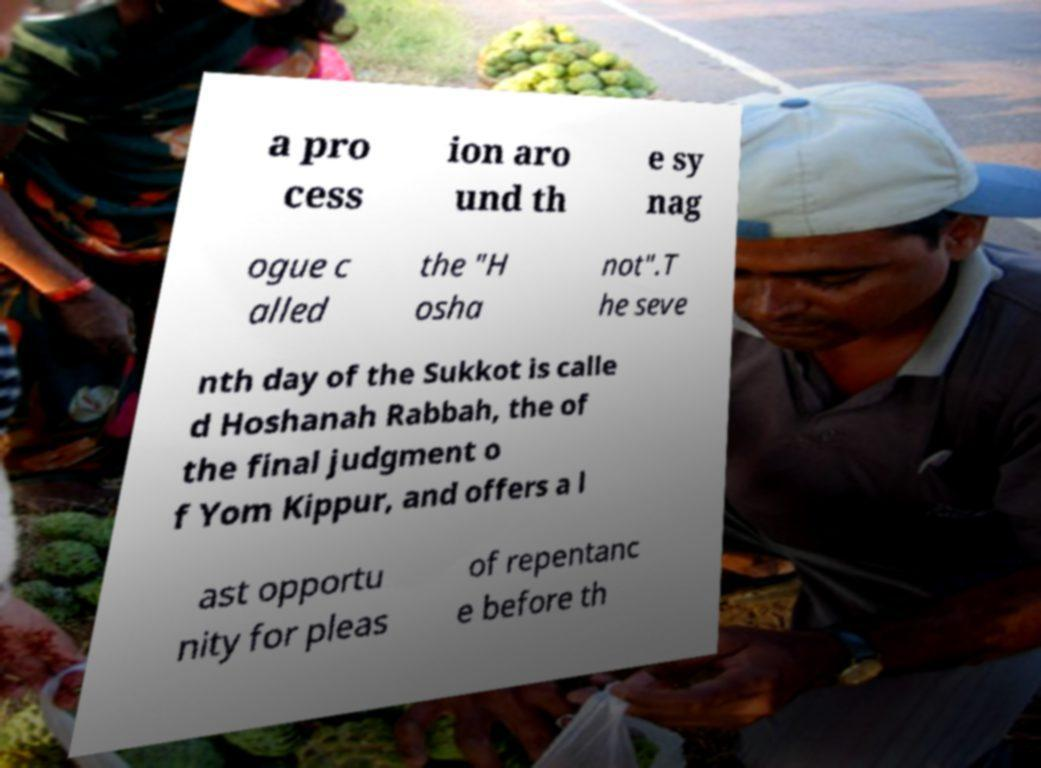Please read and relay the text visible in this image. What does it say? a pro cess ion aro und th e sy nag ogue c alled the "H osha not".T he seve nth day of the Sukkot is calle d Hoshanah Rabbah, the of the final judgment o f Yom Kippur, and offers a l ast opportu nity for pleas of repentanc e before th 